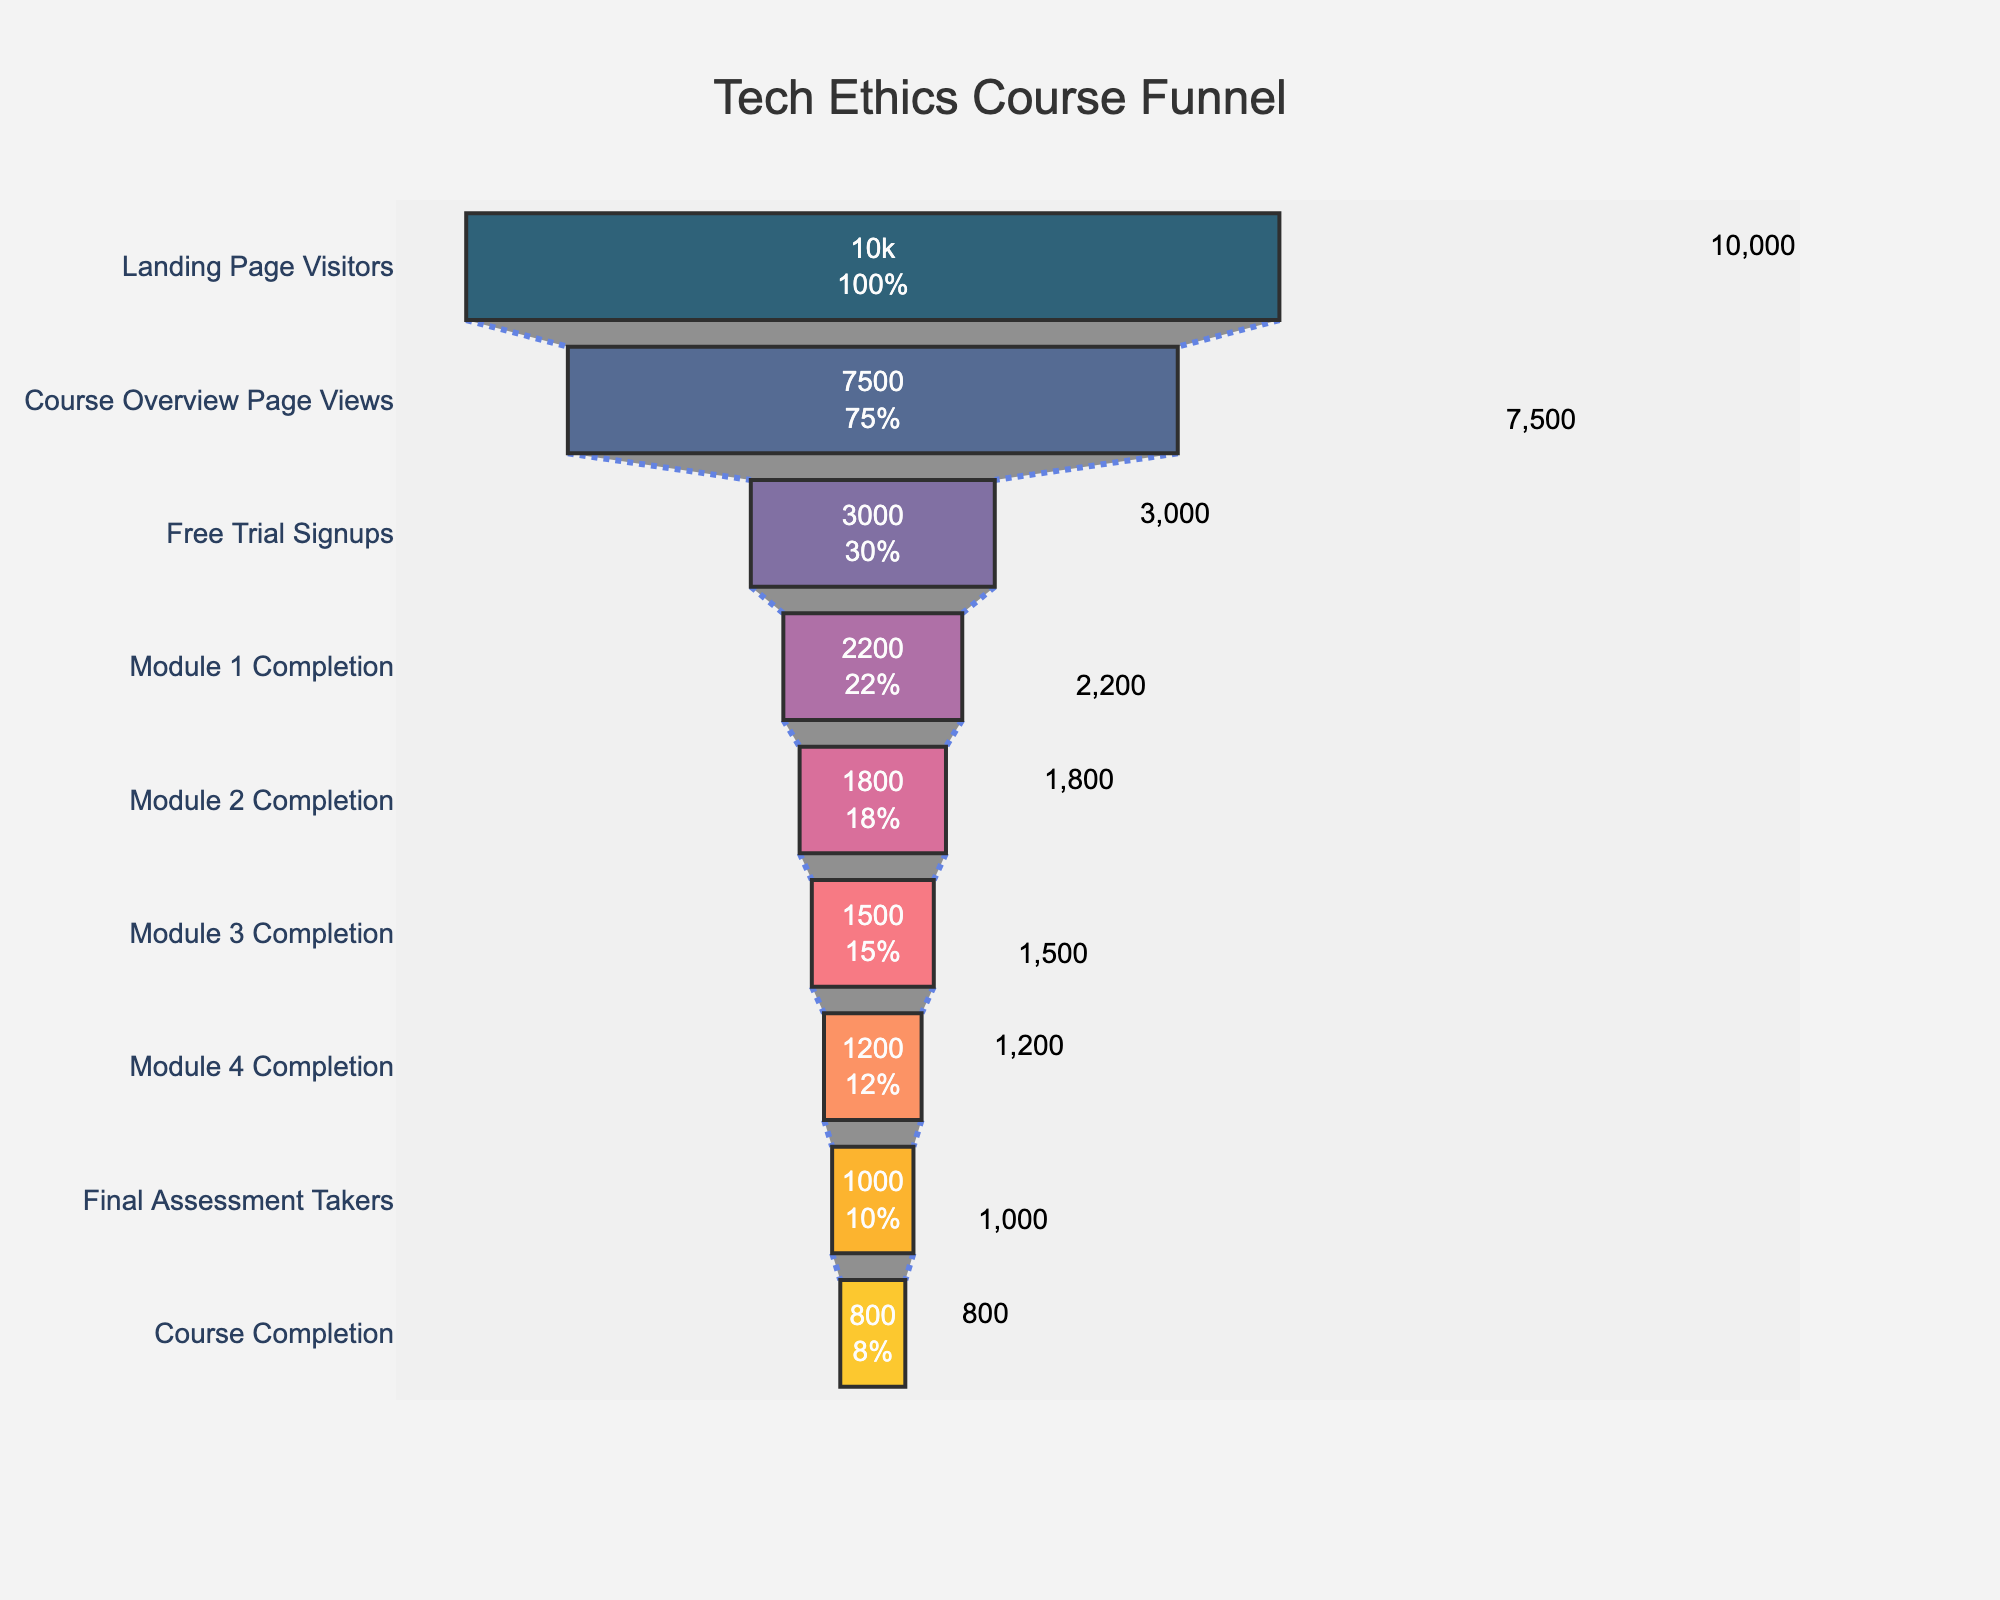What is the title of the funnel chart? The title is typically positioned at the top center of the chart. In this case, it reads "Tech Ethics Course Funnel."
Answer: Tech Ethics Course Funnel How many users viewed the Course Overview Page? By looking at the funnel chart, you can see the number of users for each stage labelled next to it. The Course Overview Page was viewed by 7,500 users.
Answer: 7,500 What is the percentage drop from Landing Page Visitors to Free Trial Signups? To find the percentage drop, first find the difference in user numbers (10,000 - 3,000 = 7,000) and then divide by the initial number of users (7,000 / 10,000). Multiply by 100 to convert to percentage.
Answer: 70% Which stage has the highest number of users? By examining the funnel from top to bottom, the stage with the highest number of users is the Landing Page Visitors, which has 10,000 users.
Answer: Landing Page Visitors How many users completed all modules but did not take the final assessment? Look at the number of users who completed Module 4 (1,200) and subtract the number of Final Assessment Takers (1,000).
Answer: 200 Which transition between stages saw the smallest drop in user numbers? To determine this, you need to calculate the difference in user numbers between each consecutive stage. The smallest drop is between Module 2 Completion (1,800) and Module 3 Completion (1,500), which is 300 users.
Answer: Module 2 to Module 3 What percentage of users who signed up for the free trial completed the course? To find this, divide the number of Course Completions (800) by the number of Free Trial Signups (3,000) and then multiply by 100 to convert to percentage. (800 / 3000) * 100
Answer: 26.67% What is the number of users who completed the final assessment but did not complete the course? Subtract the number of Course Completions (800) from the number of Final Assessment Takers (1,000).
Answer: 200 How many users dropped off between Module 3 Completion and Module 4 Completion? Subtract the number of users who completed Module 4 (1,200) from the number of users who completed Module 3 (1,500).
Answer: 300 What can you infer about user engagement through the funnel? The trend indicates that a significant portion of users drop off at each stage, with the largest drop between the Landing Page Visitors and the Free Trial Signups. This suggests that significant barriers exist early in the funnel, possibly indicating areas where user experience and conversion tactics could be improved.
Answer: Significant drop-off at each stage 